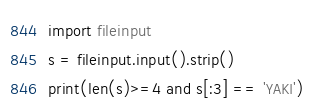Convert code to text. <code><loc_0><loc_0><loc_500><loc_500><_Python_>import fileinput
s = fileinput.input().strip()
print(len(s)>=4 and s[:3] == 'YAKI')</code> 